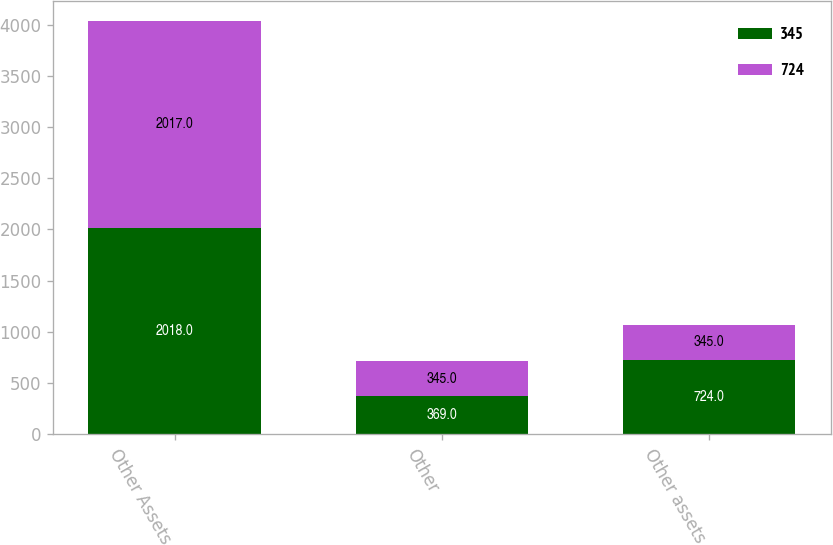Convert chart to OTSL. <chart><loc_0><loc_0><loc_500><loc_500><stacked_bar_chart><ecel><fcel>Other Assets<fcel>Other<fcel>Other assets<nl><fcel>345<fcel>2018<fcel>369<fcel>724<nl><fcel>724<fcel>2017<fcel>345<fcel>345<nl></chart> 